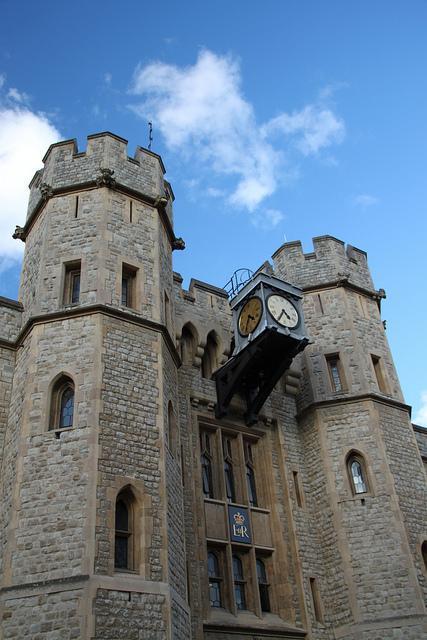How many towers are there?
Give a very brief answer. 2. How many birds are in the air flying?
Give a very brief answer. 0. 